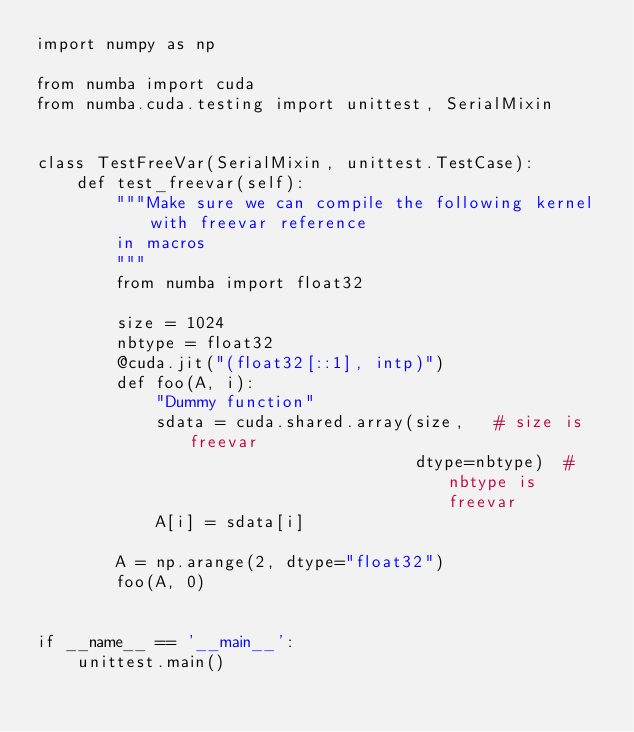Convert code to text. <code><loc_0><loc_0><loc_500><loc_500><_Python_>import numpy as np

from numba import cuda
from numba.cuda.testing import unittest, SerialMixin


class TestFreeVar(SerialMixin, unittest.TestCase):
    def test_freevar(self):
        """Make sure we can compile the following kernel with freevar reference
        in macros
        """
        from numba import float32

        size = 1024
        nbtype = float32
        @cuda.jit("(float32[::1], intp)")
        def foo(A, i):
            "Dummy function"
            sdata = cuda.shared.array(size,   # size is freevar
                                      dtype=nbtype)  # nbtype is freevar
            A[i] = sdata[i]

        A = np.arange(2, dtype="float32")
        foo(A, 0)


if __name__ == '__main__':
    unittest.main()
</code> 